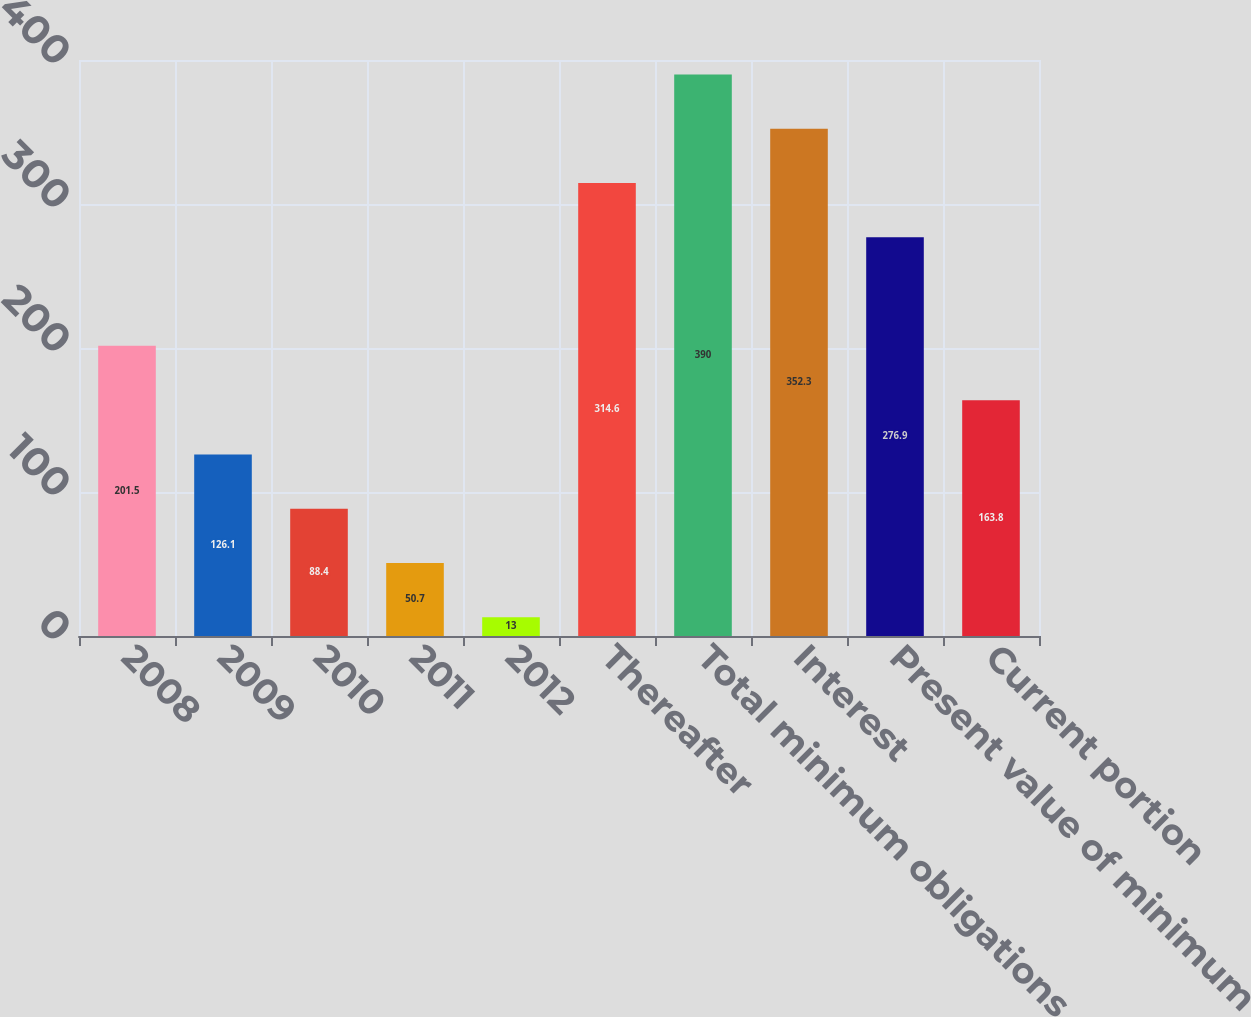Convert chart to OTSL. <chart><loc_0><loc_0><loc_500><loc_500><bar_chart><fcel>2008<fcel>2009<fcel>2010<fcel>2011<fcel>2012<fcel>Thereafter<fcel>Total minimum obligations<fcel>Interest<fcel>Present value of minimum<fcel>Current portion<nl><fcel>201.5<fcel>126.1<fcel>88.4<fcel>50.7<fcel>13<fcel>314.6<fcel>390<fcel>352.3<fcel>276.9<fcel>163.8<nl></chart> 